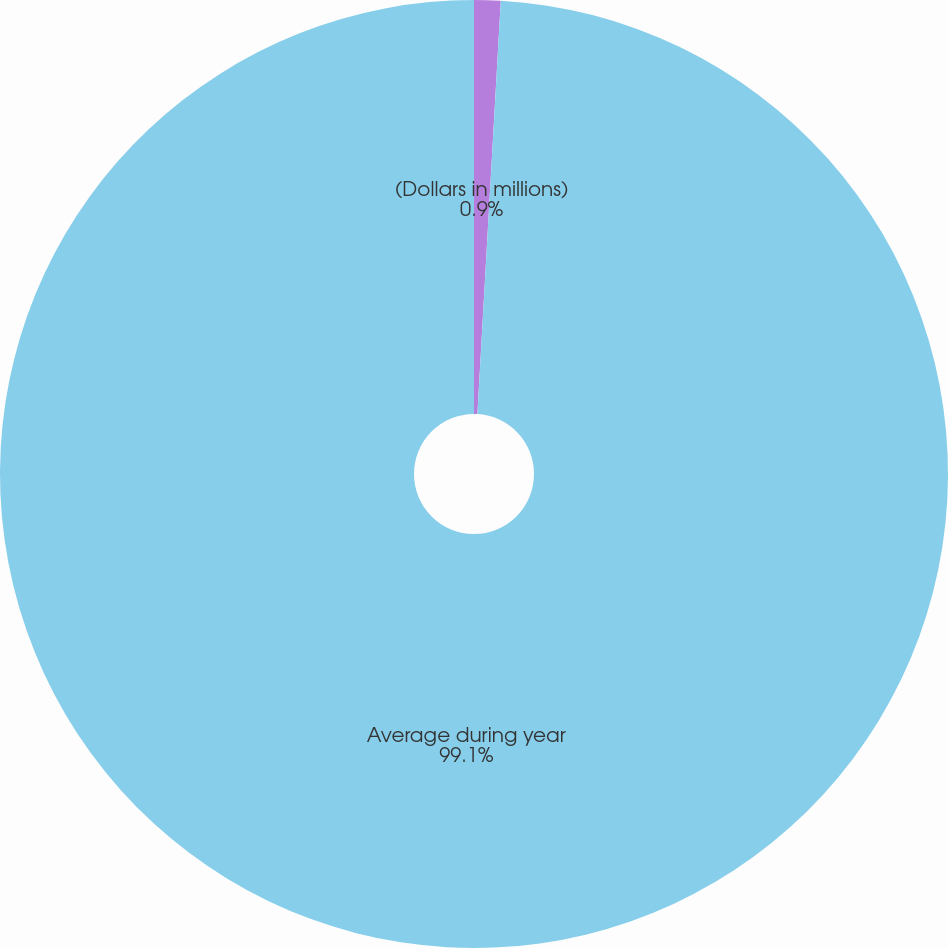Convert chart to OTSL. <chart><loc_0><loc_0><loc_500><loc_500><pie_chart><fcel>(Dollars in millions)<fcel>Average during year<nl><fcel>0.9%<fcel>99.1%<nl></chart> 